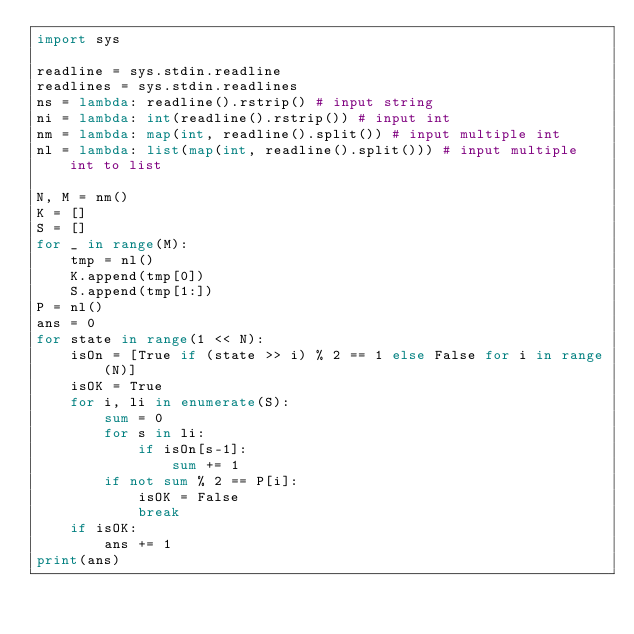Convert code to text. <code><loc_0><loc_0><loc_500><loc_500><_Python_>import sys

readline = sys.stdin.readline
readlines = sys.stdin.readlines
ns = lambda: readline().rstrip() # input string
ni = lambda: int(readline().rstrip()) # input int
nm = lambda: map(int, readline().split()) # input multiple int 
nl = lambda: list(map(int, readline().split())) # input multiple int to list

N, M = nm()
K = []
S = []
for _ in range(M):
    tmp = nl()
    K.append(tmp[0])
    S.append(tmp[1:])
P = nl()
ans = 0
for state in range(1 << N):
    isOn = [True if (state >> i) % 2 == 1 else False for i in range(N)]
    isOK = True
    for i, li in enumerate(S):
        sum = 0
        for s in li:
            if isOn[s-1]:
                sum += 1
        if not sum % 2 == P[i]:
            isOK = False
            break
    if isOK:
        ans += 1
print(ans)
</code> 